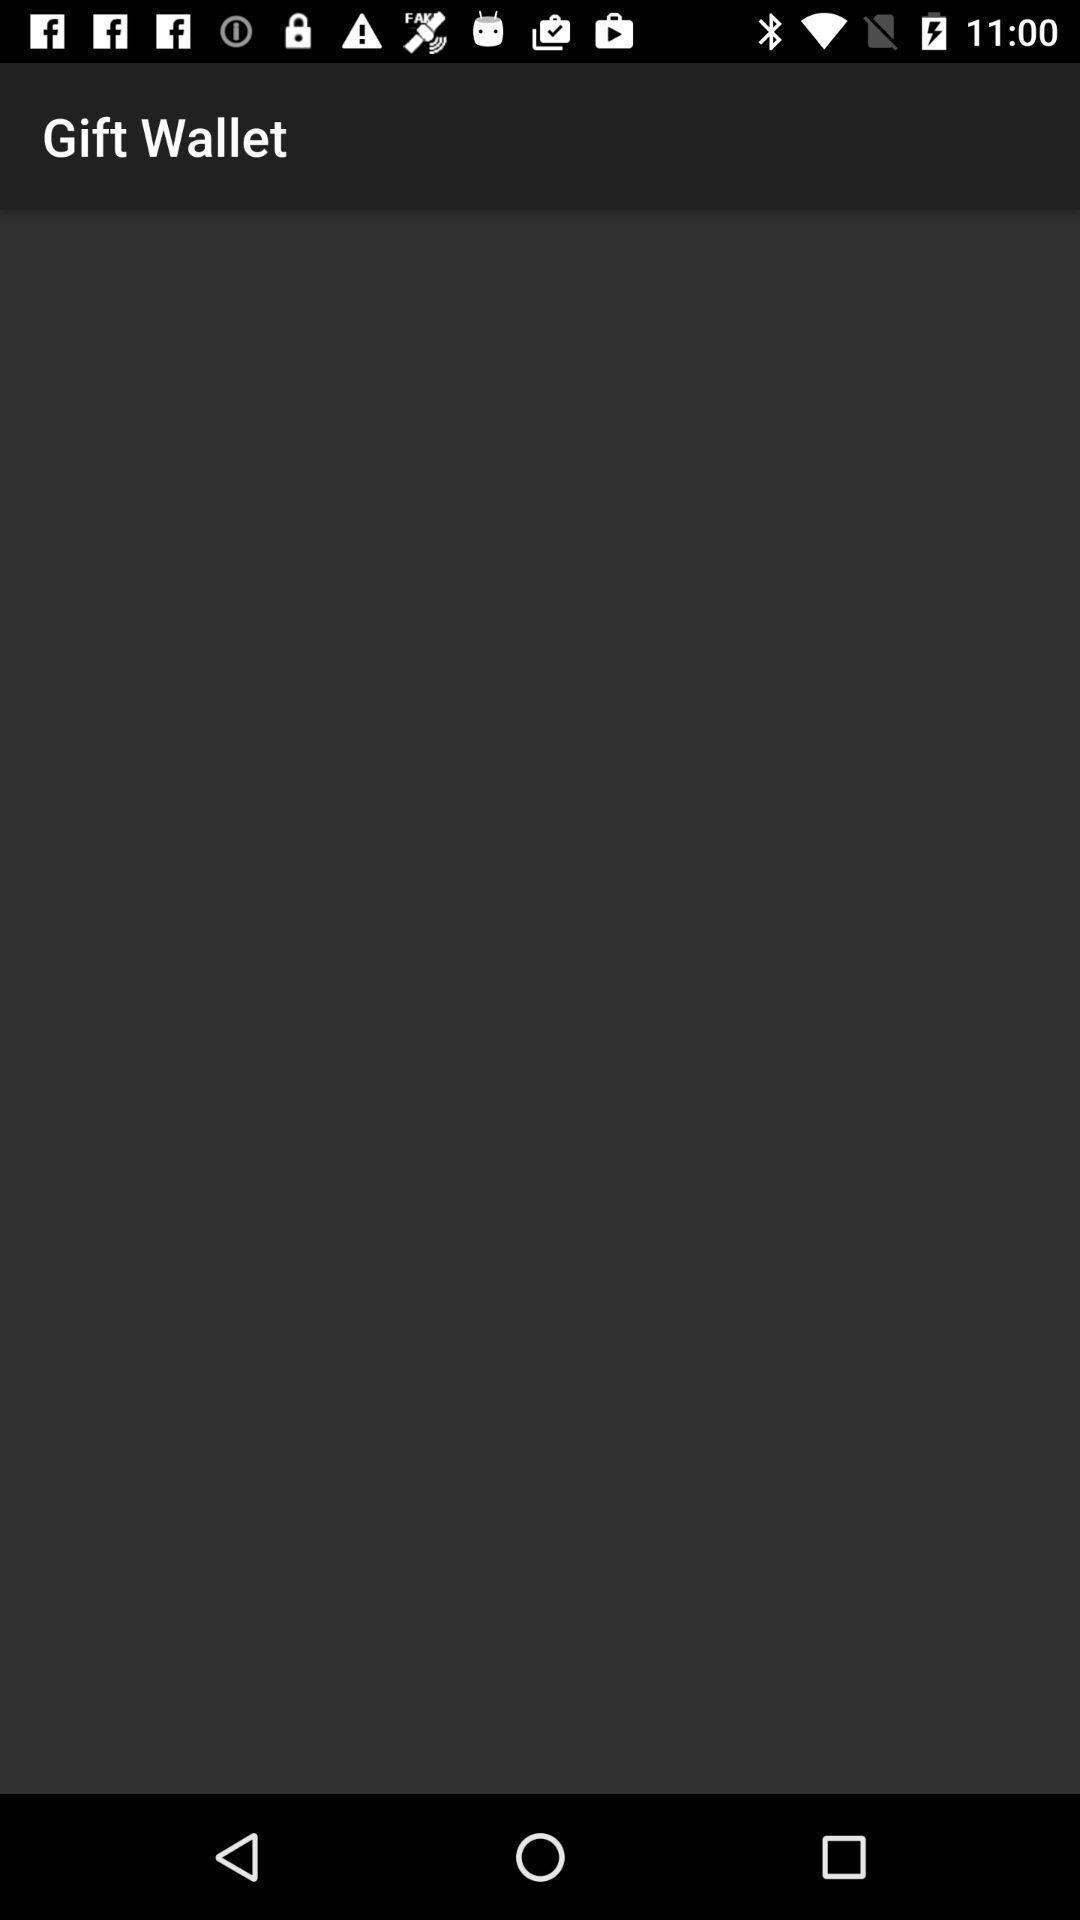Describe the content in this image. Screen page of payment application. 